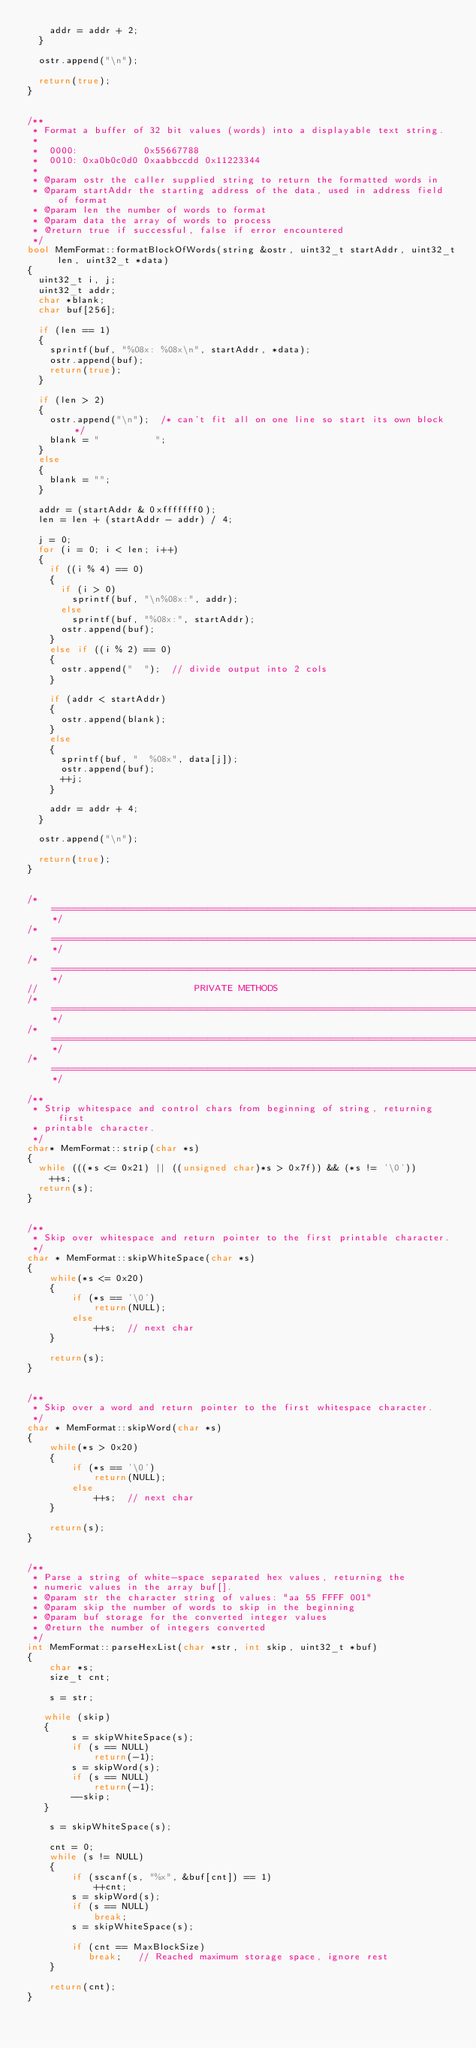<code> <loc_0><loc_0><loc_500><loc_500><_C++_>		addr = addr + 2;
	}

	ostr.append("\n");

	return(true);
}


/**
 * Format a buffer of 32 bit values (words) into a displayable text string.
 *
 *  0000:            0x55667788
 *  0010: 0xa0b0c0d0 0xaabbccdd 0x11223344
 * 
 * @param ostr the caller supplied string to return the formatted words in
 * @param startAddr the starting address of the data, used in address field of format
 * @param len the number of words to format
 * @param data the array of words to process
 * @return true if successful, false if error encountered
 */
bool MemFormat::formatBlockOfWords(string &ostr, uint32_t startAddr, uint32_t len, uint32_t *data)
{
	uint32_t i, j;
	uint32_t addr;
	char *blank;
	char buf[256];

	if (len == 1)
	{
		sprintf(buf, "%08x: %08x\n", startAddr, *data);
		ostr.append(buf);
		return(true);
	}

	if (len > 2)
	{
		ostr.append("\n");	/* can't fit all on one line so start its own block */
		blank = "          ";
	}
	else
	{
		blank = "";
	}

	addr = (startAddr & 0xfffffff0);
	len = len + (startAddr - addr) / 4;

	j = 0;
	for (i = 0; i < len; i++)
	{
		if ((i % 4) == 0)
		{
			if (i > 0)
				sprintf(buf, "\n%08x:", addr);
			else
				sprintf(buf, "%08x:", startAddr);
			ostr.append(buf);
		}
		else if ((i % 2) == 0)
		{
			ostr.append("  ");	// divide output into 2 cols
		}

		if (addr < startAddr)
		{
			ostr.append(blank);
		}
		else
		{
			sprintf(buf, "  %08x", data[j]);
			ostr.append(buf);
			++j;
		}

		addr = addr + 4;
	}

	ostr.append("\n");

	return(true);
}


/*===================================================================================*/
/*===================================================================================*/
/*===================================================================================*/
//                            PRIVATE METHODS
/*===================================================================================*/
/*===================================================================================*/
/*===================================================================================*/

/**
 * Strip whitespace and control chars from beginning of string, returning first
 * printable character.
 */
char* MemFormat::strip(char *s)
{
	while (((*s <= 0x21) || ((unsigned char)*s > 0x7f)) && (*s != '\0'))
		++s;
	return(s);
}


/**
 * Skip over whitespace and return pointer to the first printable character.
 */
char * MemFormat::skipWhiteSpace(char *s)
{
    while(*s <= 0x20)
    {
        if (*s == '\0')
            return(NULL);
        else
            ++s;  // next char
    }

    return(s);
}


/**
 * Skip over a word and return pointer to the first whitespace character.
 */
char * MemFormat::skipWord(char *s)
{
    while(*s > 0x20)
    {
        if (*s == '\0')
            return(NULL);
        else
            ++s;  // next char
    }

    return(s);
}


/**
 * Parse a string of white-space separated hex values, returning the
 * numeric values in the array buf[].
 * @param str the character string of values: "aa 55 FFFF 001"
 * @param skip the number of words to skip in the beginning
 * @param buf storage for the converted integer values
 * @return the number of integers converted
 */
int MemFormat::parseHexList(char *str, int skip, uint32_t *buf)
{
    char *s;
    size_t cnt;

    s = str;

   while (skip)
   {
        s = skipWhiteSpace(s);
        if (s == NULL)
            return(-1);
        s = skipWord(s);
        if (s == NULL)
            return(-1);
        --skip;
   }

    s = skipWhiteSpace(s);

    cnt = 0;
    while (s != NULL)
    {
        if (sscanf(s, "%x", &buf[cnt]) == 1)
            ++cnt;
        s = skipWord(s);
        if (s == NULL)
            break;
        s = skipWhiteSpace(s);
        
        if (cnt == MaxBlockSize)
           break;   // Reached maximum storage space, ignore rest
    }

    return(cnt);
}
</code> 